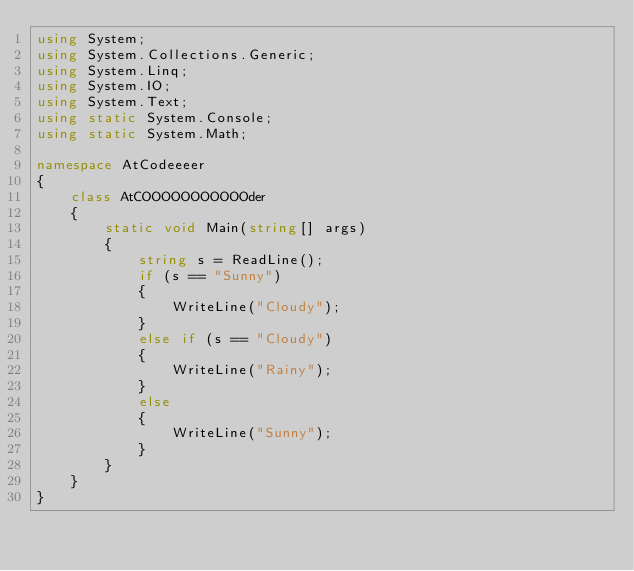Convert code to text. <code><loc_0><loc_0><loc_500><loc_500><_C#_>using System;
using System.Collections.Generic;
using System.Linq;
using System.IO;
using System.Text;
using static System.Console;
using static System.Math;

namespace AtCodeeeer
{
    class AtCOOOOOOOOOOOder
    {
        static void Main(string[] args)
        {
            string s = ReadLine();
            if (s == "Sunny")
            {
                WriteLine("Cloudy");
            }
            else if (s == "Cloudy")
            {
                WriteLine("Rainy");
            }
            else
            {
                WriteLine("Sunny");
            }
        }
    }
}

</code> 